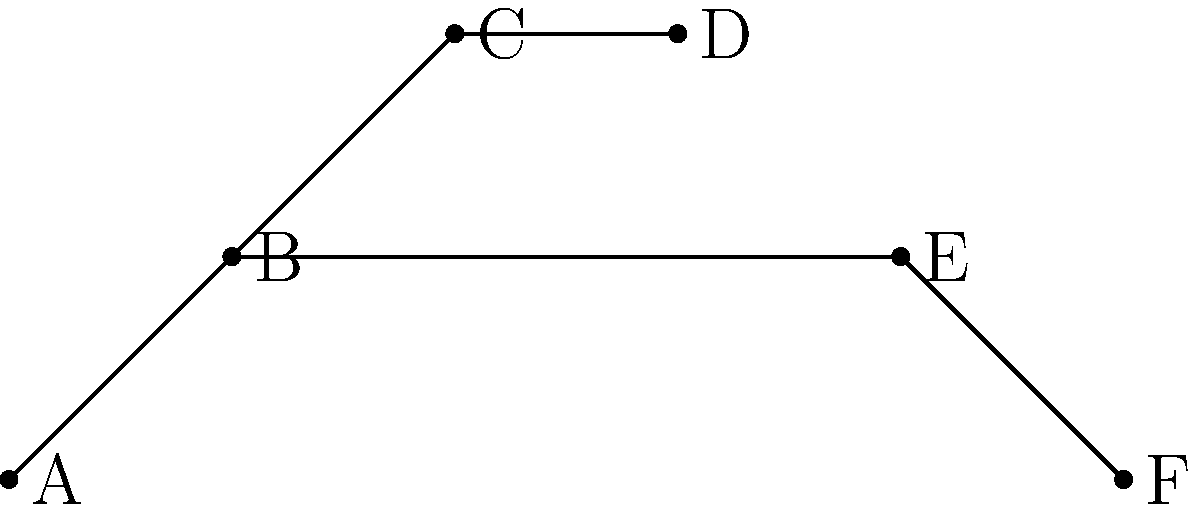Given the phylogenetic tree diagram, which species shares the most recent common ancestor with species F? To determine which species shares the most recent common ancestor with species F, we need to follow these steps:

1. Identify the position of species F on the tree.
2. Trace the branches backwards from F until we reach a node where the path splits.
3. Identify the other species that branches off from this node.
4. This species will be the one that shares the most recent common ancestor with F.

Following these steps:

1. Species F is at the bottom right of the tree.
2. Tracing backwards, we reach a node where the path splits.
3. From this node, we see that species E branches off.
4. Therefore, species E shares the most recent common ancestor with F.

This method is based on the principle that species which diverge from a common point on a phylogenetic tree are more closely related than those that diverge at earlier points. The node where E and F diverge represents their last common ancestor, which is more recent than any common ancestor shared with other species in the tree.
Answer: E 